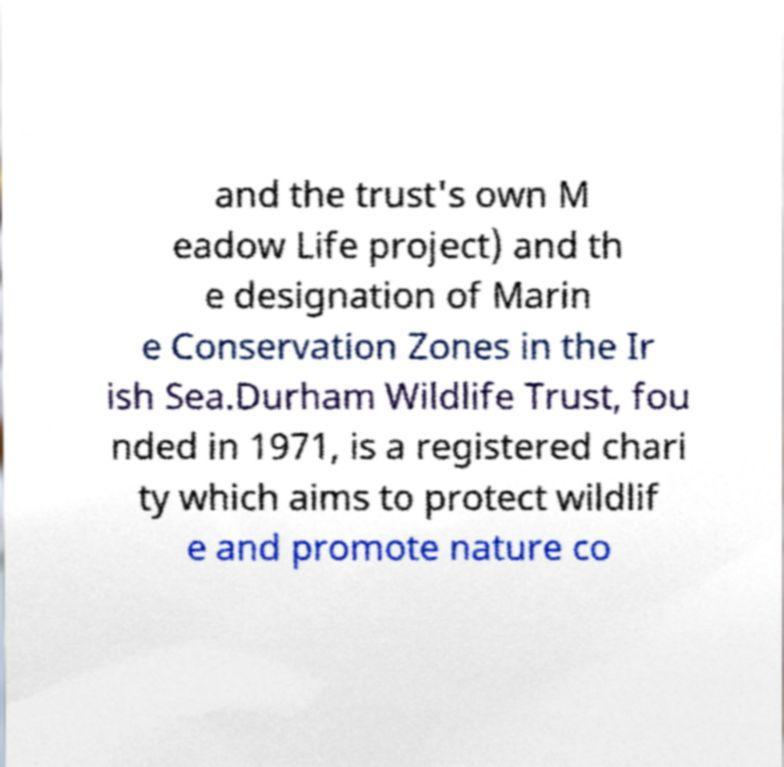Could you extract and type out the text from this image? and the trust's own M eadow Life project) and th e designation of Marin e Conservation Zones in the Ir ish Sea.Durham Wildlife Trust, fou nded in 1971, is a registered chari ty which aims to protect wildlif e and promote nature co 